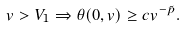Convert formula to latex. <formula><loc_0><loc_0><loc_500><loc_500>v > V _ { 1 } \Rightarrow \theta ( 0 , v ) \geq c v ^ { - \tilde { p } } .</formula> 